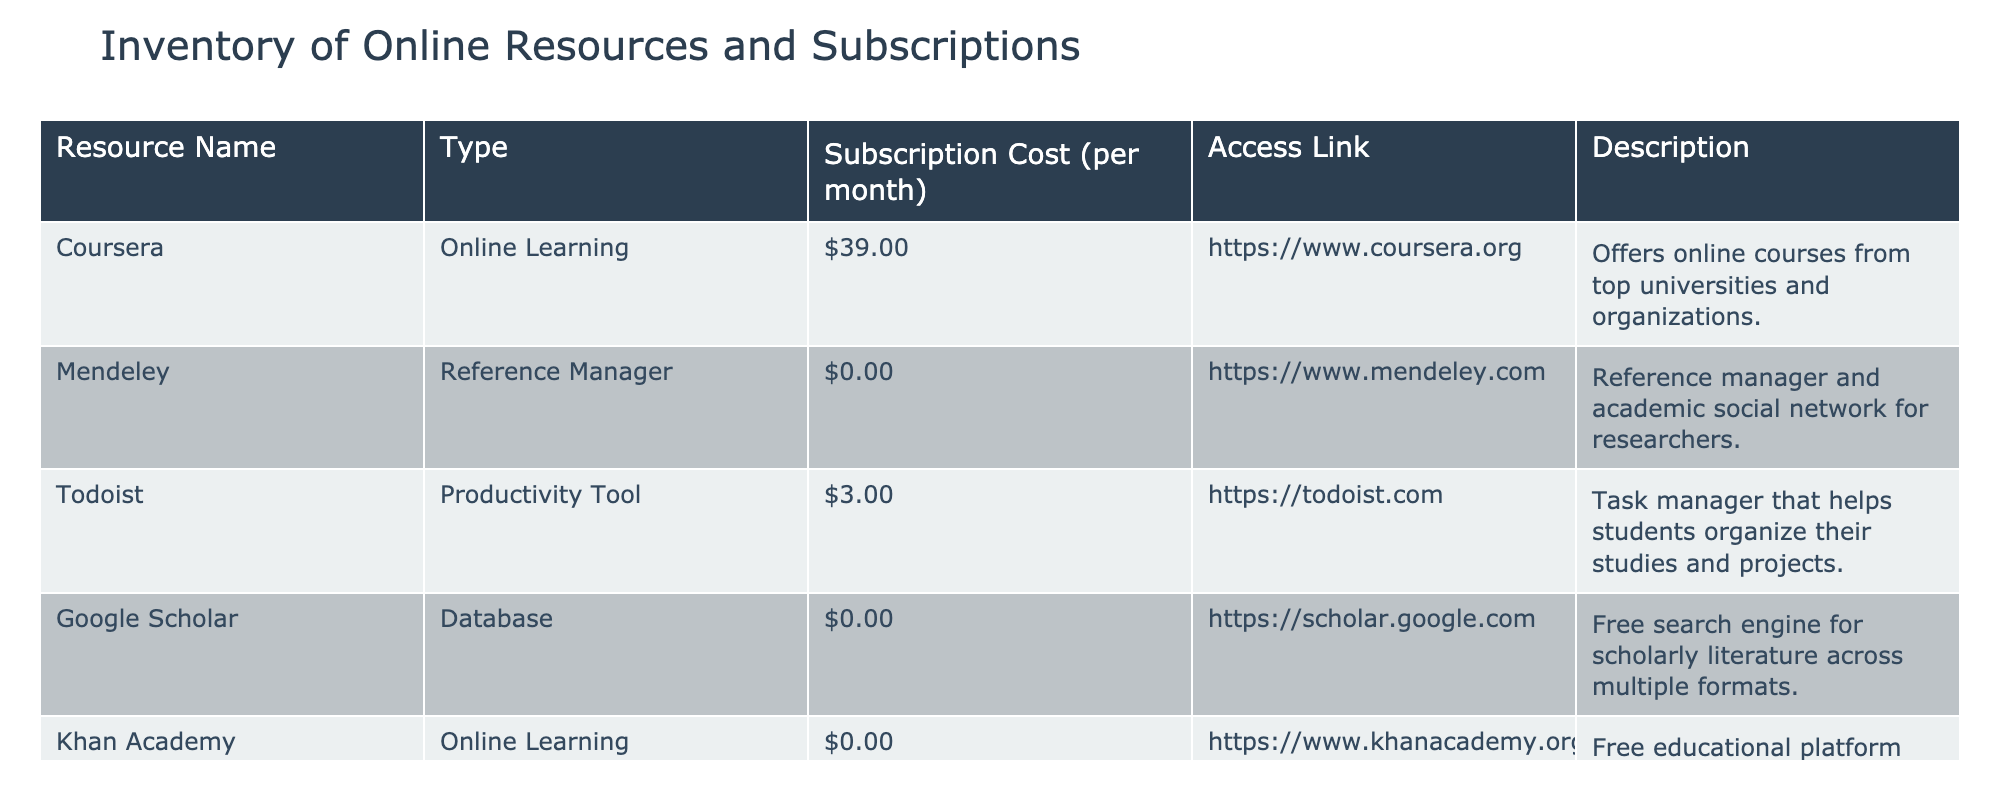What is the subscription cost for Coursera? The subscription cost is listed directly in the row for Coursera under the "Subscription Cost (per month)" column. It shows $39.00.
Answer: $39.00 How many online learning resources are provided in the table? The resources of type "Online Learning" are Coursera and Khan Academy. Counting these gives us 2 online learning resources in total.
Answer: 2 Is Mendeley a paid resource? Checking the "Subscription Cost (per month)" for Mendeley shows it is $0.00, indicating that it is free.
Answer: No Which resource has the highest subscription cost? Comparing the subscription costs across all resources, Coursera has the highest cost of $39.00, while other resources have lower or no costs.
Answer: Coursera What is the average subscription cost of the resources listed in the table? The subscription costs are $39.00, $0.00, $3.00, $0.00, and $0.00. Summing these gives $42.00, and dividing by the number of resources (5) gives an average of $42.00 / 5 = $8.40.
Answer: $8.40 How many resources are free? The resources that are free are Mendeley, Google Scholar, and Khan Academy. Counting these, we find there are 3 free resources total.
Answer: 3 Does Todoist offer a free subscription option? In the "Subscription Cost (per month)" column, Todoist shows a cost of $3.00, indicating that it does not have a free option.
Answer: No If we were to consider only the online learning resources, what would be their combined cost? The costs for the online learning resources are $39.00 for Coursera and $0.00 for Khan Academy. Adding these values gives a combined cost of $39.00 + $0.00 = $39.00.
Answer: $39.00 What percentage of the listed resources are databases? There is one database listed, Google Scholar, out of a total of five resources. Calculating the percentage gives (1 / 5) * 100 = 20%.
Answer: 20% 